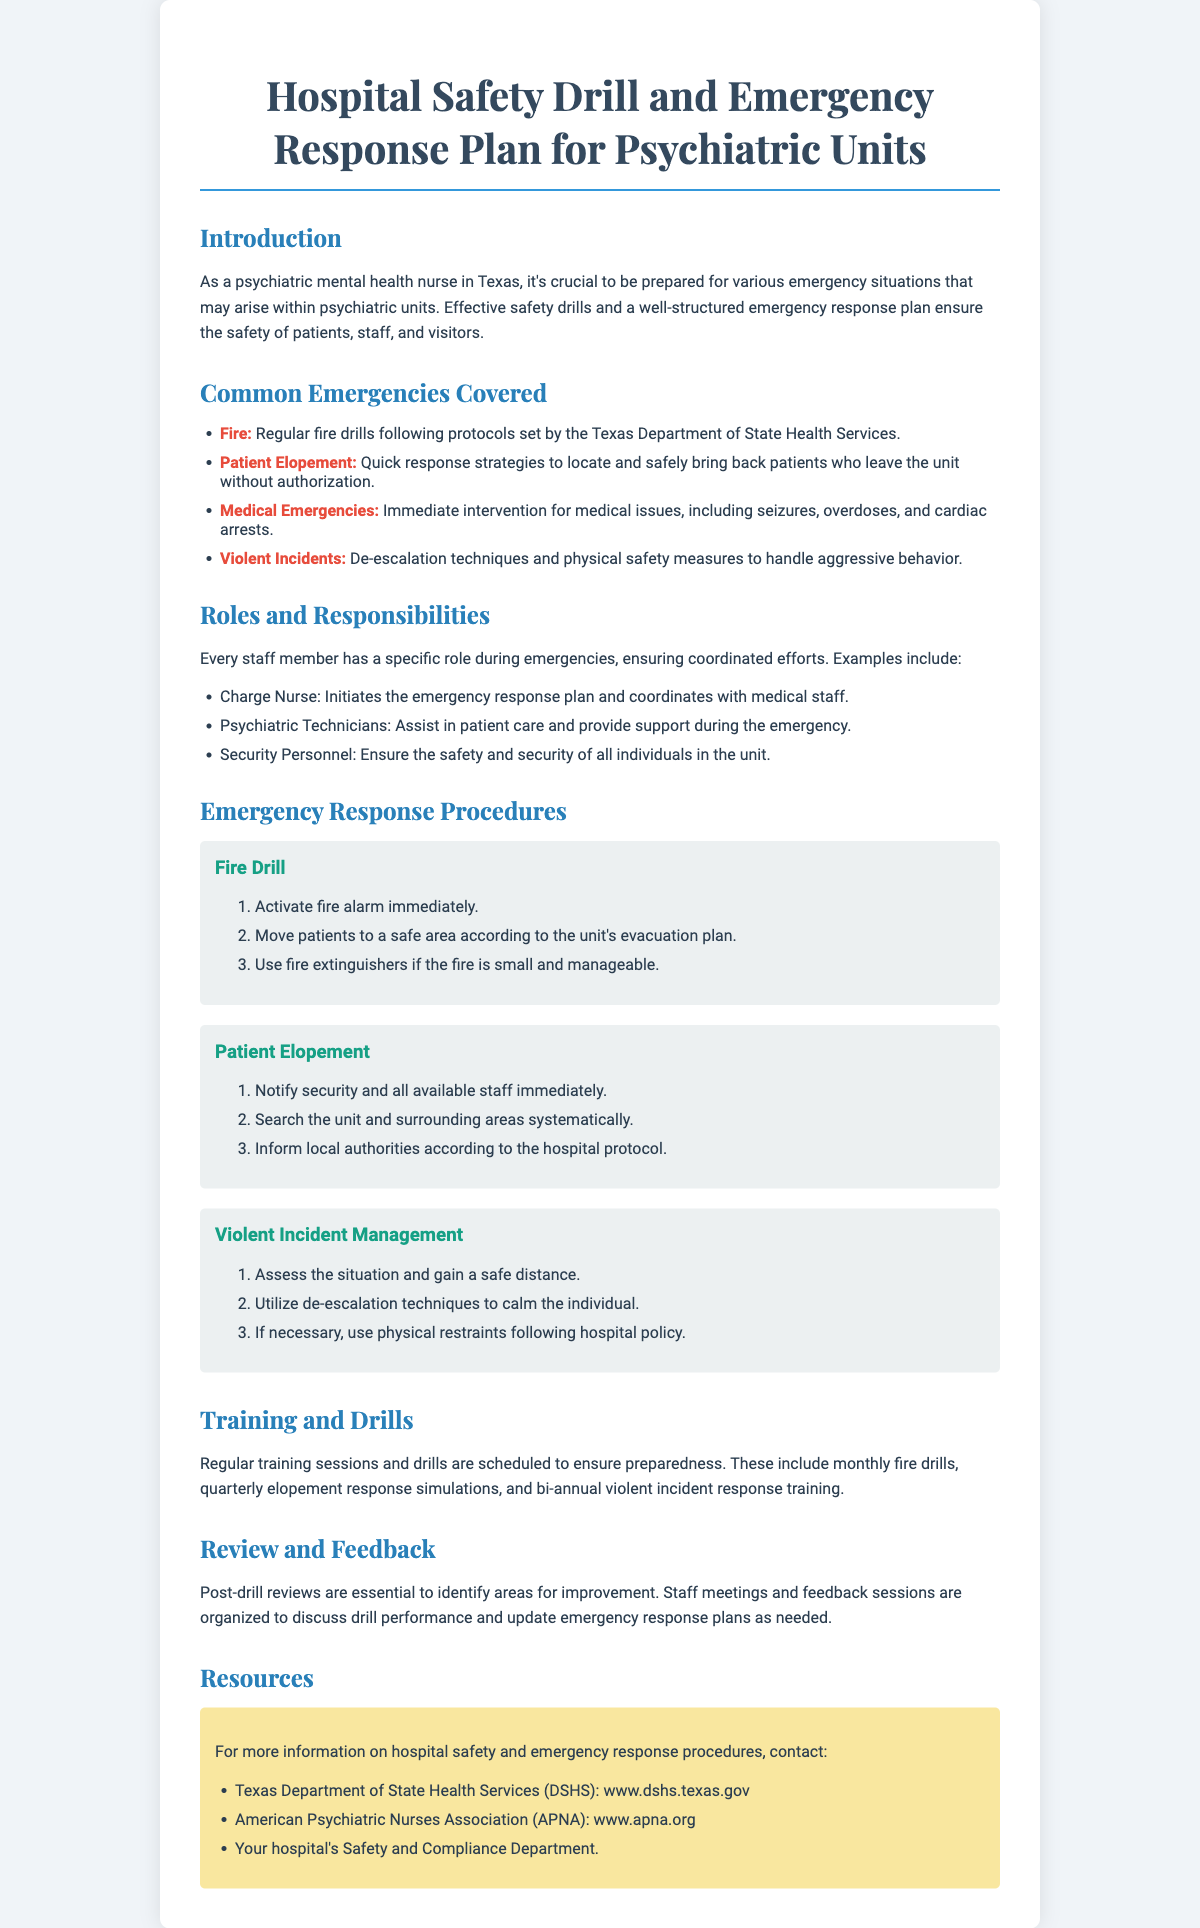what is the title of the document? The title of the document is presented in the header, emphasizing the primary focus on safety and emergency response.
Answer: Hospital Safety Drill and Emergency Response Plan for Psychiatric Units which department's protocols are followed for fire drills? The document mentions that fire drills follow protocols set by a specific department, indicating regulatory compliance.
Answer: Texas Department of State Health Services how often are fire drills conducted? The document states the frequency of specific training sessions, including drills, indicating systematic preparedness.
Answer: Monthly who initiates the emergency response plan? The responsibilities of various staff members are outlined, highlighting the charge nurse's specific role during emergencies.
Answer: Charge Nurse what should be done immediately when a patient elopes? The document provides a clear initial response step for handling patient elopement, emphasizing prompt action.
Answer: Notify security and all available staff immediately how many types of emergencies are covered in the document? The document lists the types of emergencies addressed, providing clarity on the scope of the response plan.
Answer: Four which techniques are utilized for managing violent incidents? The emergency procedures section outlines specific strategies that should be employed to de-escalate violent situations.
Answer: De-escalation techniques what is included in the post-drill reviews? The document describes the purpose of post-drill reviews, which focus on continuous improvement and feedback mechanisms.
Answer: Identify areas for improvement where can more information on hospital safety be found? The resources section lists organizations that provide additional information, indicating where to seek further guidance.
Answer: Texas Department of State Health Services (DSHS) 